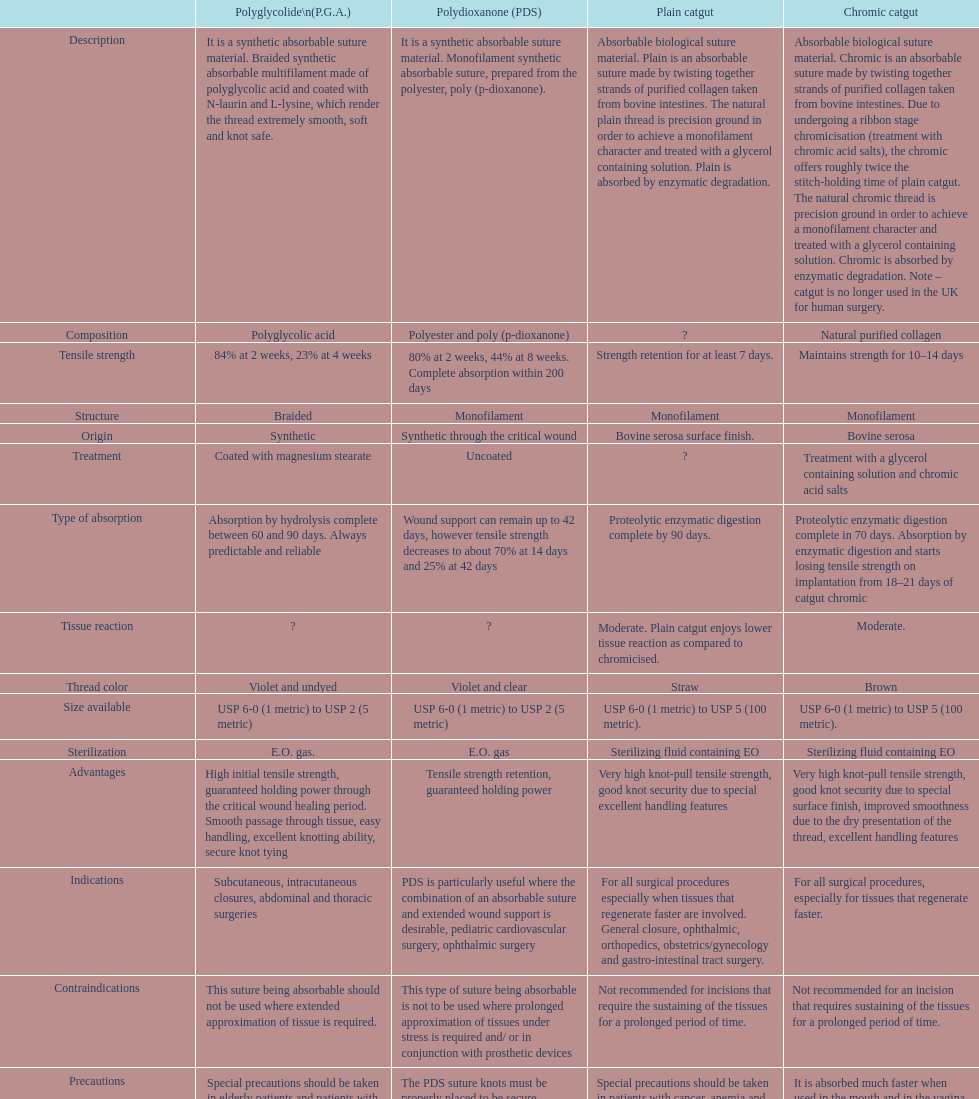What sort of sutures are no longer employed in the u.k. for human surgical procedures? Chromic catgut. 